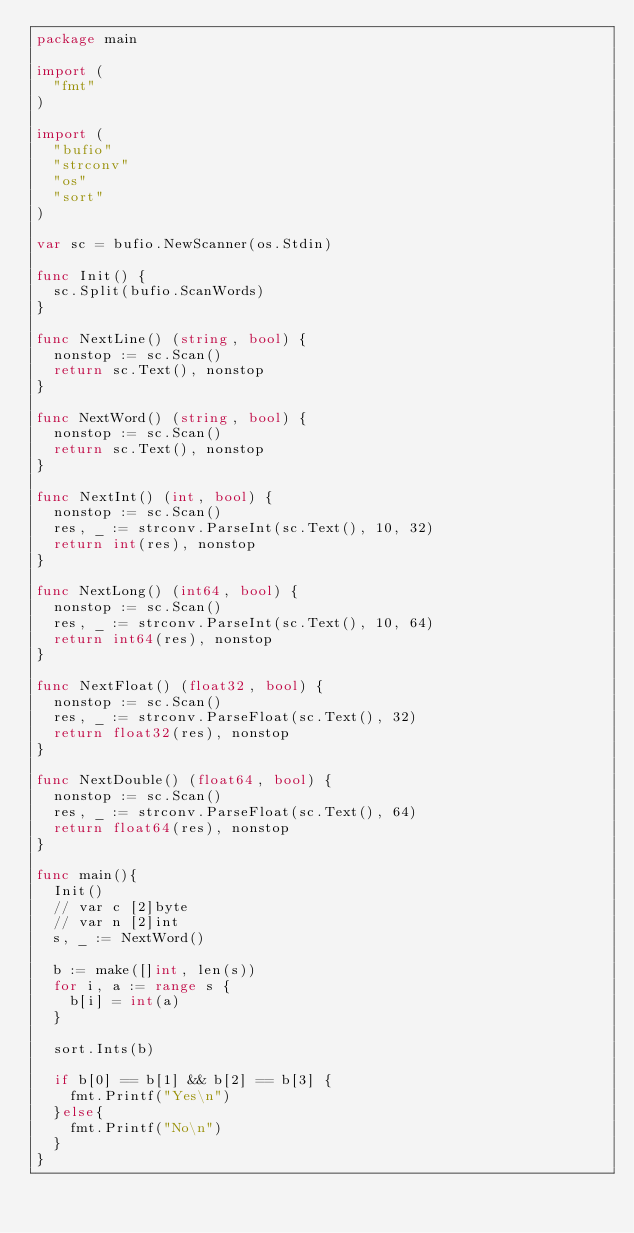Convert code to text. <code><loc_0><loc_0><loc_500><loc_500><_Go_>package main

import (
  "fmt"
)

import (
  "bufio"
  "strconv"
  "os"
  "sort"
)

var sc = bufio.NewScanner(os.Stdin)

func Init() {
  sc.Split(bufio.ScanWords)
}

func NextLine() (string, bool) {
  nonstop := sc.Scan()
  return sc.Text(), nonstop
}

func NextWord() (string, bool) {
  nonstop := sc.Scan()
  return sc.Text(), nonstop
}

func NextInt() (int, bool) {
  nonstop := sc.Scan()
  res, _ := strconv.ParseInt(sc.Text(), 10, 32)
  return int(res), nonstop
}

func NextLong() (int64, bool) {
  nonstop := sc.Scan()
  res, _ := strconv.ParseInt(sc.Text(), 10, 64)
  return int64(res), nonstop
}

func NextFloat() (float32, bool) {
  nonstop := sc.Scan()
  res, _ := strconv.ParseFloat(sc.Text(), 32)
  return float32(res), nonstop
}

func NextDouble() (float64, bool) {
  nonstop := sc.Scan()
  res, _ := strconv.ParseFloat(sc.Text(), 64)
  return float64(res), nonstop
}

func main(){
  Init()
  // var c [2]byte
  // var n [2]int
  s, _ := NextWord()

  b := make([]int, len(s))
  for i, a := range s {
    b[i] = int(a)
  }

  sort.Ints(b)

  if b[0] == b[1] && b[2] == b[3] {
    fmt.Printf("Yes\n")
  }else{
    fmt.Printf("No\n")
  }
}
</code> 